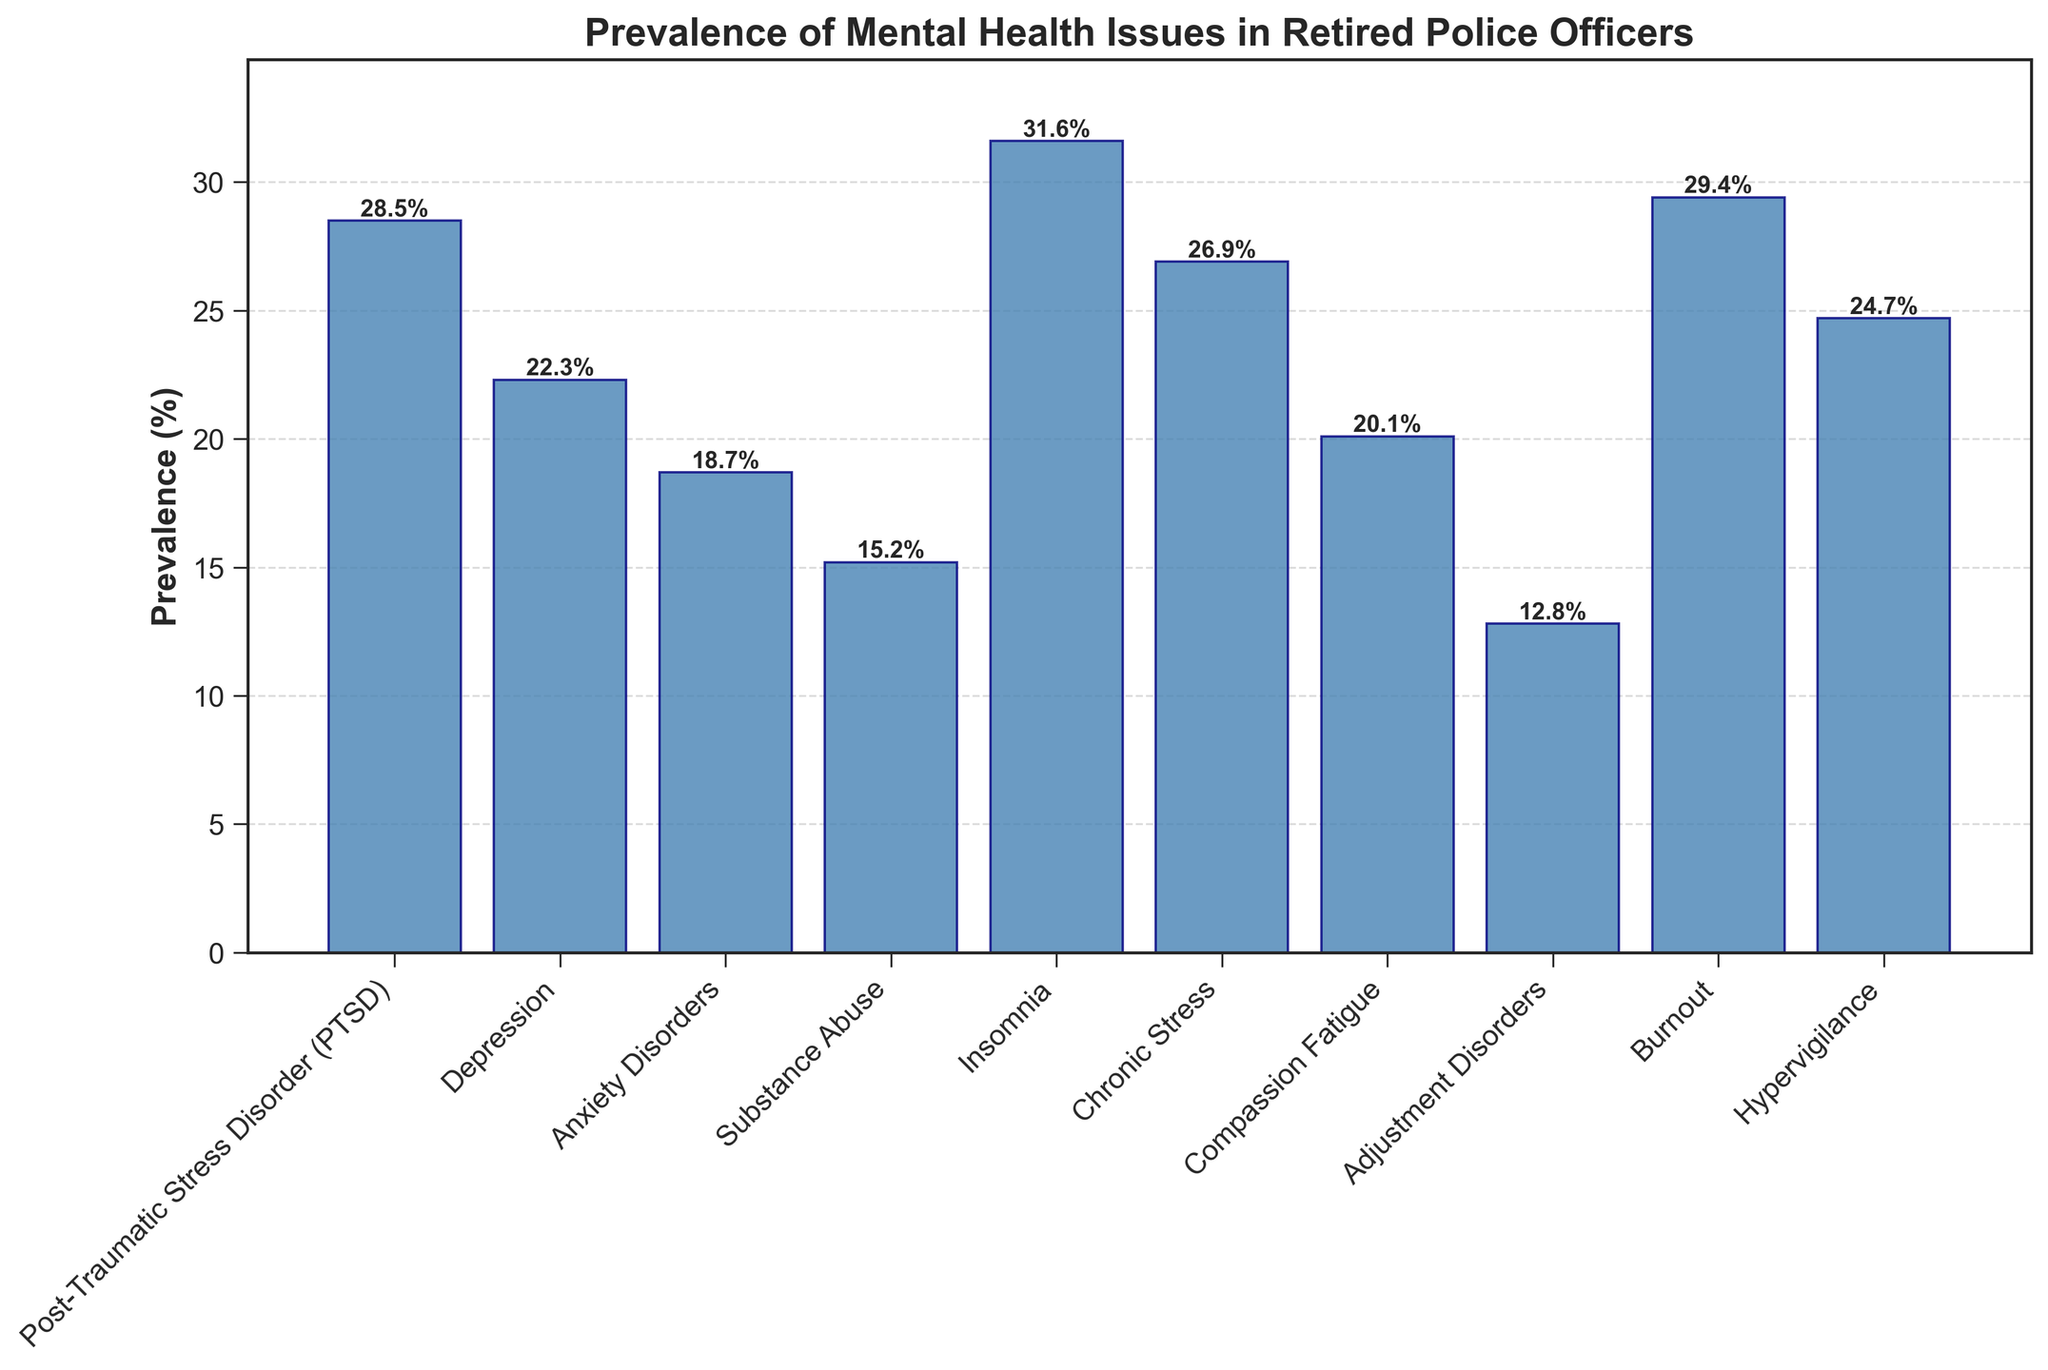What's the most prevalent mental health issue among retired police officers? The highest bar in the plot represents the issue with the greatest prevalence. Insomnia has the tallest bar with a prevalence of 31.6%.
Answer: Insomnia Which mental health issue has a slightly lower prevalence than PTSD? By comparing the height of the bars, Burnout has a prevalence slightly lower than PTSD which is 29.4% compared to PTSD's 28.5%.
Answer: Burnout How does the prevalence of substance abuse compare to chronic stress? By comparing the bar heights, Substance Abuse has a prevalence of 15.2%, which is lower than Chronic Stress at 26.9%.
Answer: Chronic Stress is higher What's the total prevalence of PTSD, Depression, and Anxiety Disorders combined? Sum the prevalence percentages of PTSD (28.5%), Depression (22.3%), and Anxiety Disorders (18.7%). 28.5 + 22.3 + 18.7 = 69.5%.
Answer: 69.5% What's the least prevalent mental health issue reported? Adjustment Disorders has the lowest bar height indicating it has the least prevalence at 12.8%.
Answer: Adjustment Disorders Rank the following issues from highest to lowest prevalence: Burnout, Compassion Fatigue, and Hypervigilance. Compare the bar heights: Burnout (29.4%), Hypervigilance (24.7%), Compassion Fatigue (20.1%).
Answer: Burnout > Hypervigilance > Compassion Fatigue What is the average prevalence of all reported mental health issues? Add all the prevalence percentages and divide by the number of issues: (28.5 + 22.3 + 18.7 + 15.2 + 31.6 + 26.9 + 20.1 + 12.8 + 29.4 + 24.7) / 10 = 23.02%.
Answer: 23.02% Compare and contrast the prevalence of Compassion Fatigue and Anxiety Disorders. Compassion Fatigue has a prevalence of 20.1%, whereas Anxiety Disorders have a prevalence of 18.7%. Both are relatively close but Compassion Fatigue is slightly higher.
Answer: Compassion Fatigue is higher If we group PTSD and chronic stress together, what’s their combined prevalence? Add the prevalence percentages of PTSD (28.5%) and Chronic Stress (26.9%). 28.5 + 26.9 = 55.4%.
Answer: 55.4% Which mental health issue has a prevalence closest to 25%? From the plot, Hypervigilance has a prevalence of 24.7%, which is closest to 25%.
Answer: Hypervigilance 